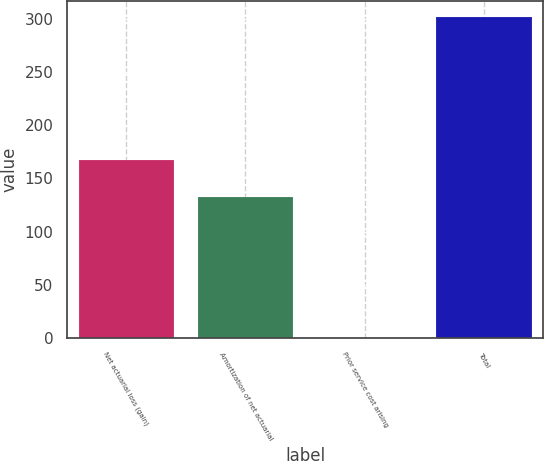<chart> <loc_0><loc_0><loc_500><loc_500><bar_chart><fcel>Net actuarial loss (gain)<fcel>Amortization of net actuarial<fcel>Prior service cost arising<fcel>Total<nl><fcel>167.7<fcel>132.4<fcel>0.1<fcel>301.6<nl></chart> 